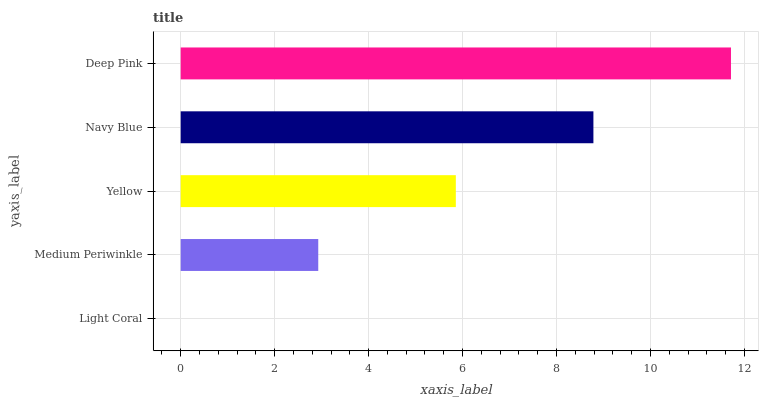Is Light Coral the minimum?
Answer yes or no. Yes. Is Deep Pink the maximum?
Answer yes or no. Yes. Is Medium Periwinkle the minimum?
Answer yes or no. No. Is Medium Periwinkle the maximum?
Answer yes or no. No. Is Medium Periwinkle greater than Light Coral?
Answer yes or no. Yes. Is Light Coral less than Medium Periwinkle?
Answer yes or no. Yes. Is Light Coral greater than Medium Periwinkle?
Answer yes or no. No. Is Medium Periwinkle less than Light Coral?
Answer yes or no. No. Is Yellow the high median?
Answer yes or no. Yes. Is Yellow the low median?
Answer yes or no. Yes. Is Navy Blue the high median?
Answer yes or no. No. Is Navy Blue the low median?
Answer yes or no. No. 